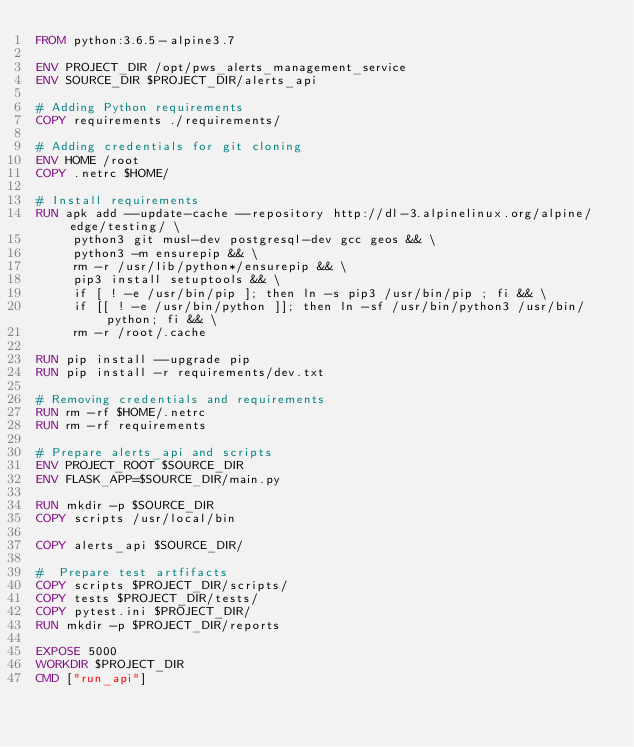<code> <loc_0><loc_0><loc_500><loc_500><_Dockerfile_>FROM python:3.6.5-alpine3.7

ENV PROJECT_DIR /opt/pws_alerts_management_service
ENV SOURCE_DIR $PROJECT_DIR/alerts_api

# Adding Python requirements
COPY requirements ./requirements/

# Adding credentials for git cloning
ENV HOME /root
COPY .netrc $HOME/

# Install requirements
RUN apk add --update-cache --repository http://dl-3.alpinelinux.org/alpine/edge/testing/ \
     python3 git musl-dev postgresql-dev gcc geos && \
     python3 -m ensurepip && \
     rm -r /usr/lib/python*/ensurepip && \
     pip3 install setuptools && \
     if [ ! -e /usr/bin/pip ]; then ln -s pip3 /usr/bin/pip ; fi && \
     if [[ ! -e /usr/bin/python ]]; then ln -sf /usr/bin/python3 /usr/bin/python; fi && \
     rm -r /root/.cache

RUN pip install --upgrade pip
RUN pip install -r requirements/dev.txt

# Removing credentials and requirements
RUN rm -rf $HOME/.netrc
RUN rm -rf requirements

# Prepare alerts_api and scripts
ENV PROJECT_ROOT $SOURCE_DIR
ENV FLASK_APP=$SOURCE_DIR/main.py

RUN mkdir -p $SOURCE_DIR
COPY scripts /usr/local/bin

COPY alerts_api $SOURCE_DIR/

#  Prepare test artfifacts
COPY scripts $PROJECT_DIR/scripts/
COPY tests $PROJECT_DIR/tests/
COPY pytest.ini $PROJECT_DIR/
RUN mkdir -p $PROJECT_DIR/reports

EXPOSE 5000
WORKDIR $PROJECT_DIR
CMD ["run_api"]
</code> 